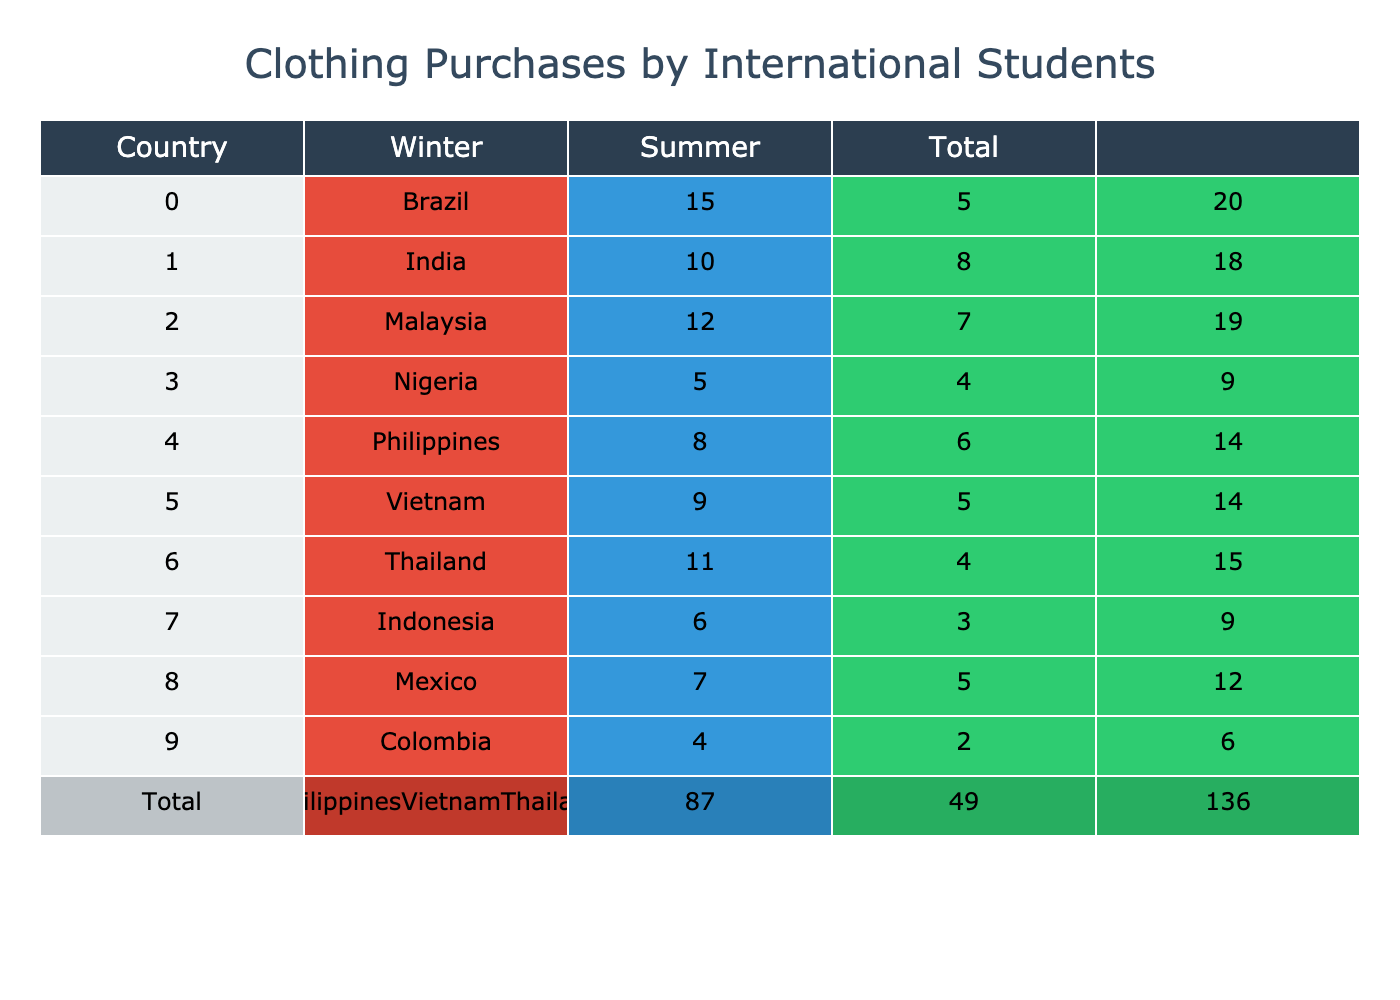What is the total number of clothing purchases by students from India? To find the total clothing purchases by students from India, we look at the row corresponding to India in the table. We sum the values of 'Clothing Purchases (Winter)' which is 10 and 'Clothing Purchases (Summer)' which is 8. Adding these together gives us 10 + 8 = 18.
Answer: 18 Which country made the least number of winter clothing purchases? To identify which country made the least number of winter clothing purchases, we examine the 'Clothing Purchases (Winter)' column. The minimum value is 4, associated with Colombia.
Answer: Colombia What is the average number of summer clothing purchases across all countries? To calculate the average summer clothing purchases, we first sum the values in the 'Clothing Purchases (Summer)' column, which is 5 + 8 + 7 + 4 + 6 + 5 + 4 + 3 + 5 + 2 = 54. There are 10 countries, so we divide the total by 10: 54/10 = 5.4.
Answer: 5.4 Do students from Thailand buy more summer clothing than students from Vietnam? We check the summer clothing purchases for Thailand and Vietnam. Thailand has 4 purchases while Vietnam has 5. Since 4 is less than 5, the statement is false.
Answer: No Which country has the highest overall clothing purchases? To find which country has the highest overall clothing purchases, we need to combine winter and summer purchases for each country. Calculating totals: Brazil 20, India 18, Malaysia 19, Nigeria 9, Philippines 14, Vietnam 14, Thailand 15, Indonesia 9, Mexico 12, Colombia 6. The maximum is 20, associated with Brazil.
Answer: Brazil What is the difference in total clothing purchases between students from Brazil and Nigeria? First, we find the total clothing purchases for both countries. Brazil has 20 (15+5) and Nigeria has 9 (5+4). The difference is calculated as 20 - 9 = 11, indicating that Brazil bought 11 more items.
Answer: 11 Which countries purchased more than 10 items in total? We review each country's total purchases: Brazil (20), India (18), Malaysia (19), Philippines (14), and Thailand (15). These four countries exceed 10 total purchases. Thus, the countries are Brazil, India, Malaysia, and Philippines.
Answer: Brazil, India, Malaysia, Philippines Is it true that all countries purchased more winter clothing than summer clothing? We need to look at each country’s winter and summer purchases. For instance, Brazil (15 > 5), India (10 > 8), Malaysia (12 > 7), Nigeria (5 > 4), Philippines (8 > 6), Vietnam (9 > 5), Thailand (11 > 4), Indonesia (6 > 3), Mexico (7 > 5), and Colombia (4 > 2) shows that all countries do purchase more winter clothing.
Answer: Yes 